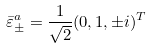Convert formula to latex. <formula><loc_0><loc_0><loc_500><loc_500>\bar { \varepsilon } ^ { a } _ { \pm } = \frac { 1 } { \sqrt { 2 } } ( 0 , 1 , \pm i ) ^ { T }</formula> 